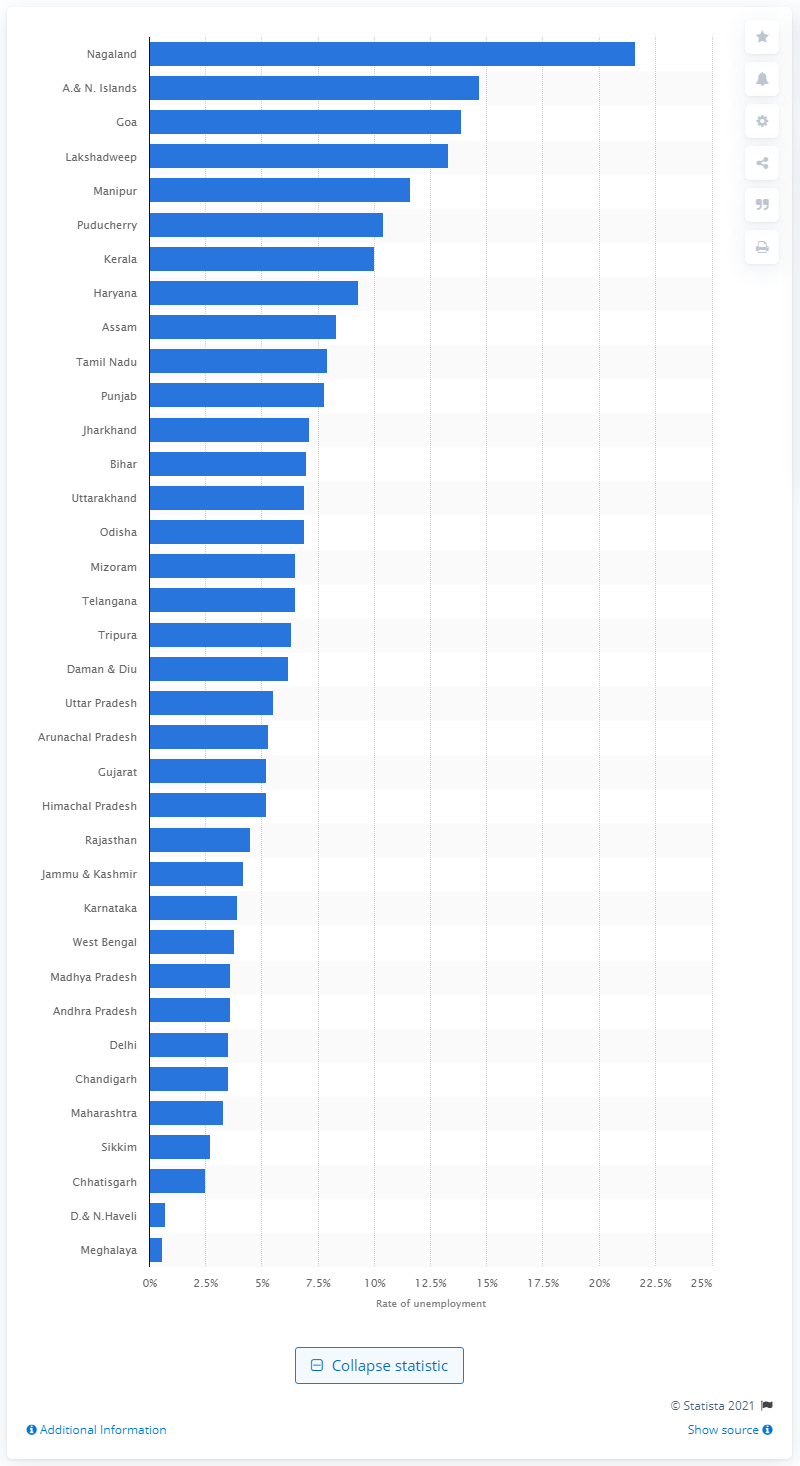Highlight a few significant elements in this photo. According to data collected between July 2017 and June 2018, Nagaland had the highest unemployment rate among all areas surveyed. 